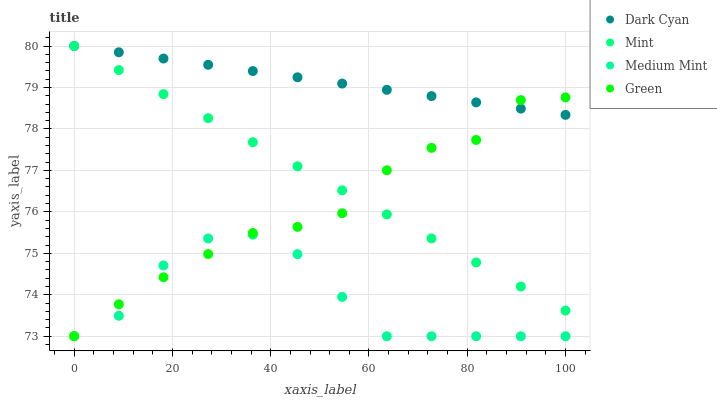Does Medium Mint have the minimum area under the curve?
Answer yes or no. Yes. Does Dark Cyan have the maximum area under the curve?
Answer yes or no. Yes. Does Green have the minimum area under the curve?
Answer yes or no. No. Does Green have the maximum area under the curve?
Answer yes or no. No. Is Dark Cyan the smoothest?
Answer yes or no. Yes. Is Green the roughest?
Answer yes or no. Yes. Is Medium Mint the smoothest?
Answer yes or no. No. Is Medium Mint the roughest?
Answer yes or no. No. Does Medium Mint have the lowest value?
Answer yes or no. Yes. Does Green have the lowest value?
Answer yes or no. No. Does Mint have the highest value?
Answer yes or no. Yes. Does Green have the highest value?
Answer yes or no. No. Is Medium Mint less than Mint?
Answer yes or no. Yes. Is Mint greater than Medium Mint?
Answer yes or no. Yes. Does Dark Cyan intersect Green?
Answer yes or no. Yes. Is Dark Cyan less than Green?
Answer yes or no. No. Is Dark Cyan greater than Green?
Answer yes or no. No. Does Medium Mint intersect Mint?
Answer yes or no. No. 